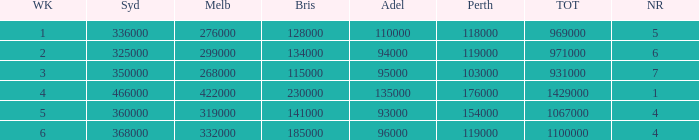What was the total rating on week 3?  931000.0. 